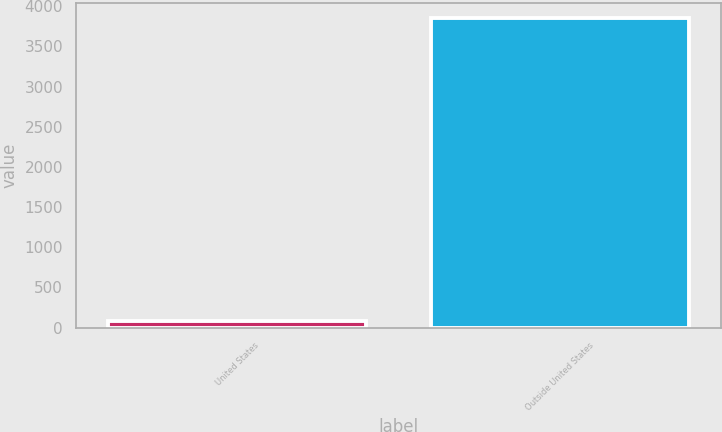Convert chart. <chart><loc_0><loc_0><loc_500><loc_500><bar_chart><fcel>United States<fcel>Outside United States<nl><fcel>86<fcel>3848<nl></chart> 